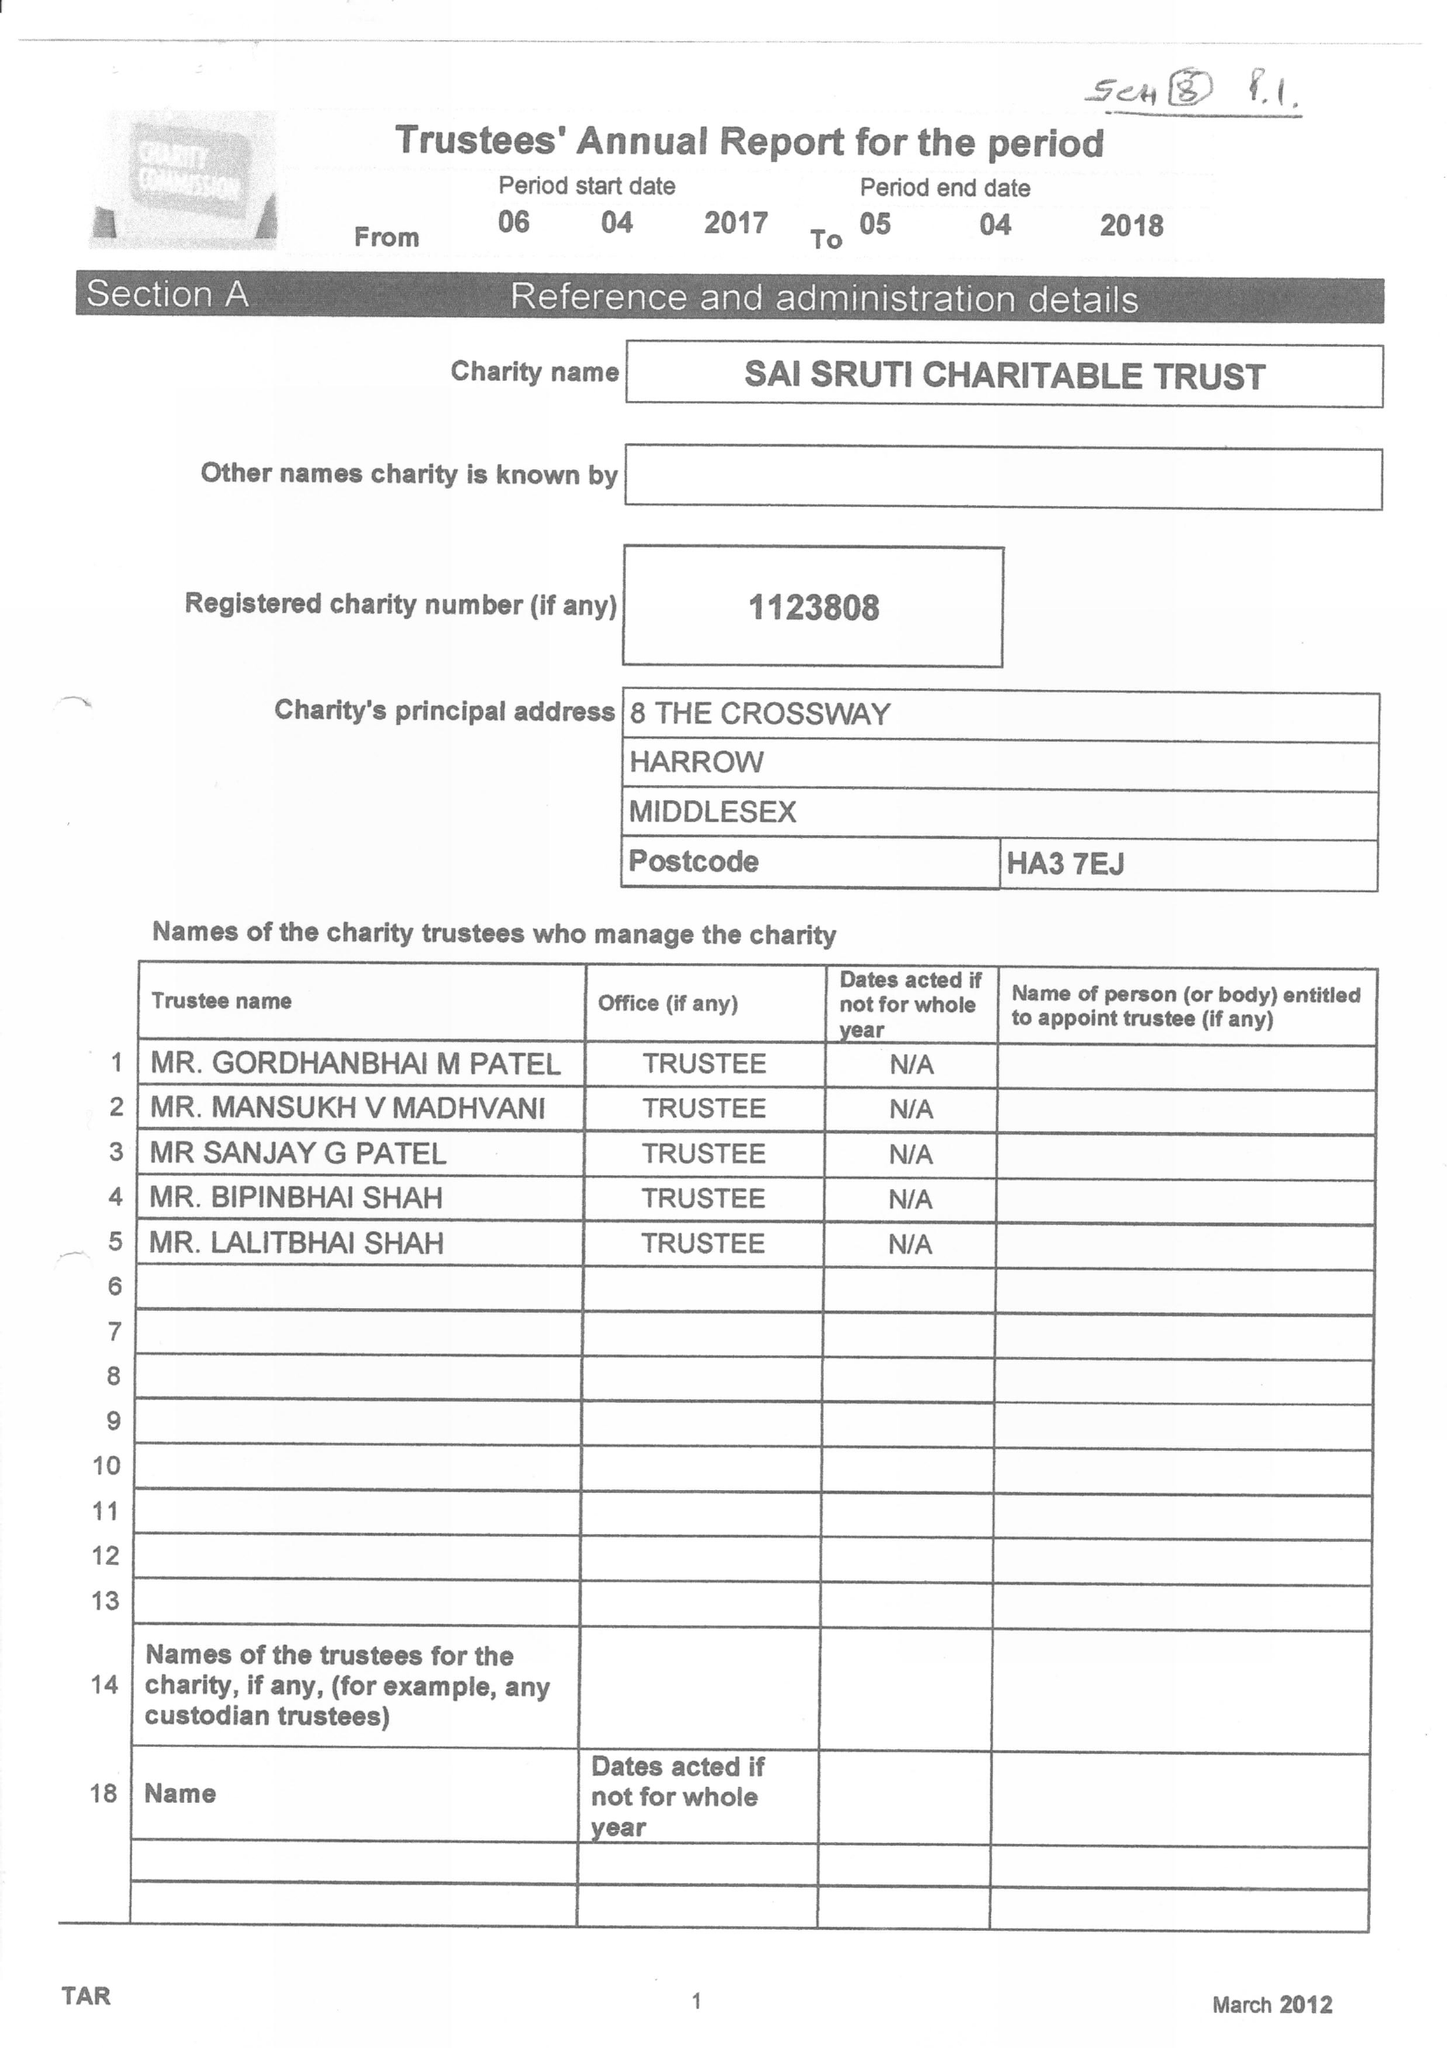What is the value for the address__postcode?
Answer the question using a single word or phrase. HA3 7EJ 